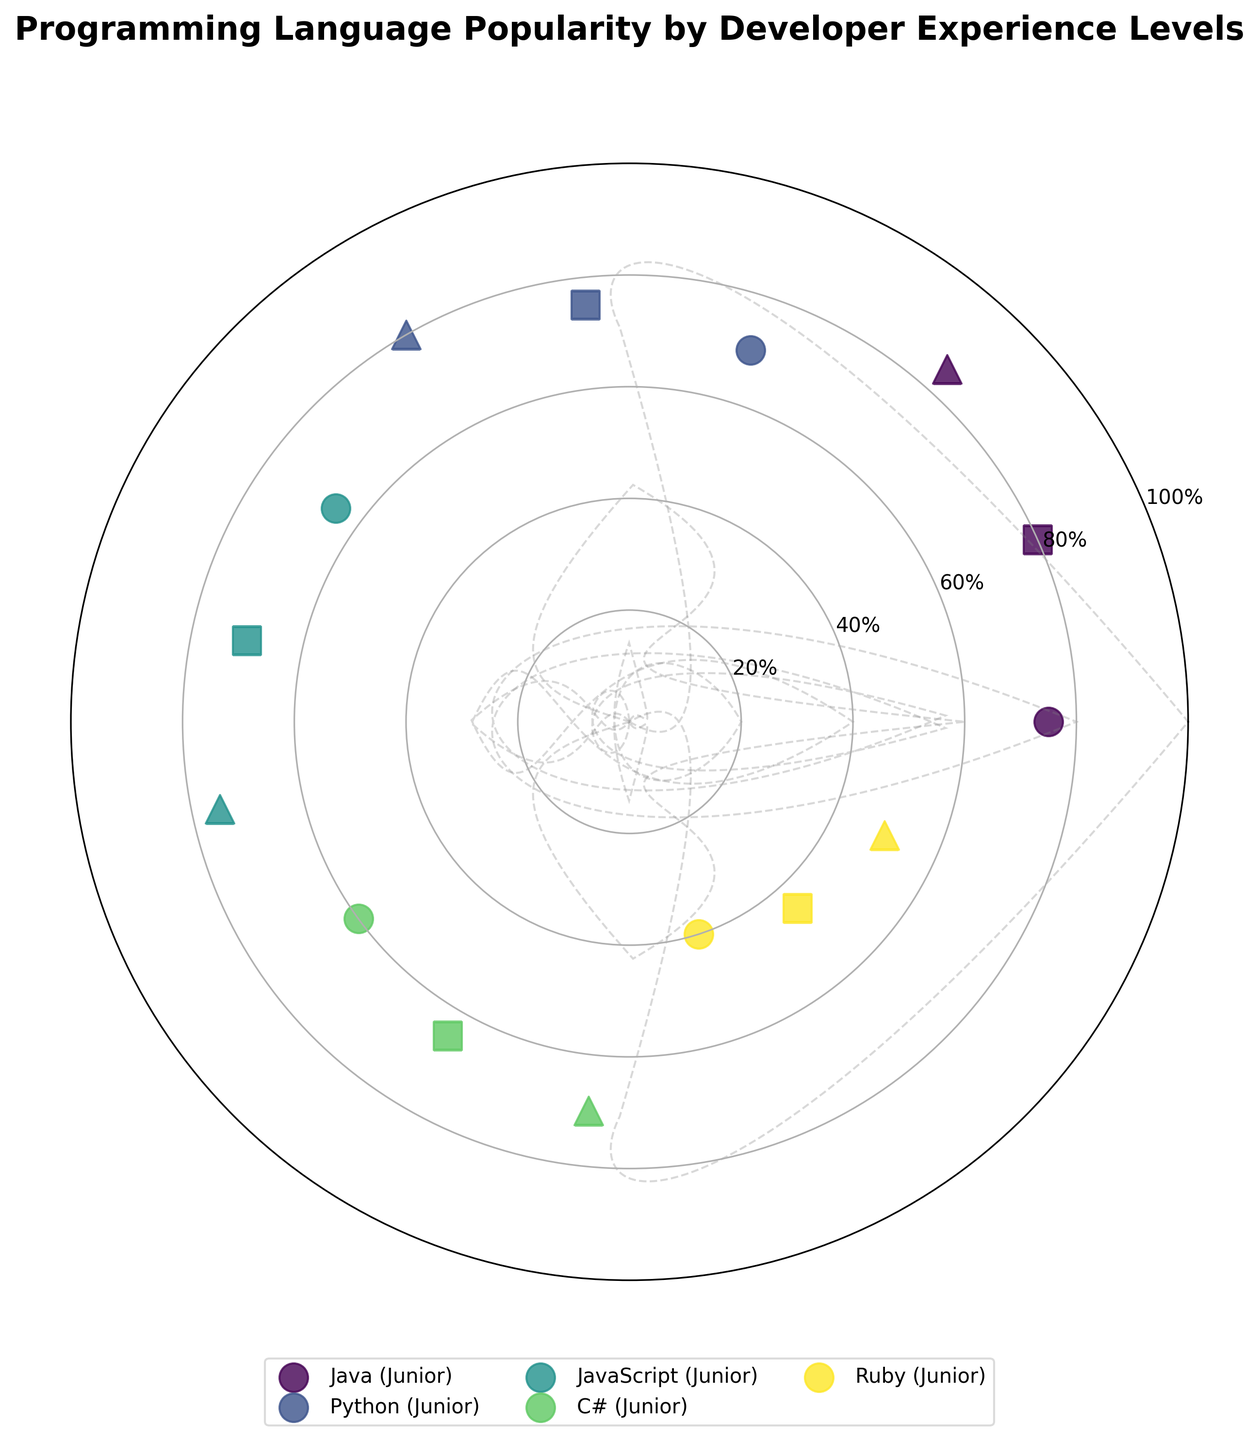What is the title of the figure? The title of the figure is found at the top of the plot, indicating the main subject of the graph.
Answer: Programming Language Popularity by Developer Experience Levels How many programming languages are shown in the figure? Count the number of unique labels in the plot representing different programming languages.
Answer: 5 Which experience level has the highest popularity for Java? Identify the markers associated with Java and compare their popularity values across the different experience levels. Note that there is one scatter point for each level per language. The Senior level has the highest popularity at 85.
Answer: Senior What is the average popularity of Java across all experience levels? Sum the popularity percentages across Junior, Mid, and Senior levels for Java and divide by 3. Calculating: (75 + 80 + 85) / 3 = 240 / 3 = 80
Answer: 80 Which programming language has the lowest popularity among Junior developers? Look for the markers representing programming languages within the Junior category and identify the one with the smallest value. Ruby has the lowest popularity at 40.
Answer: Ruby Is there any programming language that has the same popularity percentage across any two experience levels? Compare the popularity values for each language across Junior, Mid, and Senior levels to check if any two experience levels have the same value. None of the languages has the same popularity percentage across different experience levels.
Answer: No What is the most popular programming language among Senior developers? Identify the Senior category markers and find the language with the highest popularity value. Java has the highest popularity of 85 among Senior developers.
Answer: Java For which programming language does the popularity increase consistently with experience level? Check each language and observe if the popularity values increase as the experience level transitions from Junior to Mid and then to Senior. Java shows consistent increase: 75 (Junior), 80 (Mid), and 85 (Senior).
Answer: Java How does the popularity of Python compare between Junior and Mid developers? Find the popularity values for Python in both Junior and Mid levels and compare them. Python has a popularity of 70 among Junior developers and 75 among Mid developers.
Answer: Mid is greater Which experience level sees the highest overall average popularity of programming languages? Calculate the average popularity for all recorded languages at each experience level and compare those values. Junior: (75 + 70 + 65 + 60 + 40) / 5 = 62; Mid: (80 + 75 + 70 + 65 + 45) / 5 = 67; Senior: (85 + 80 + 75 + 70 + 50) / 5 = 72
Answer: Senior 